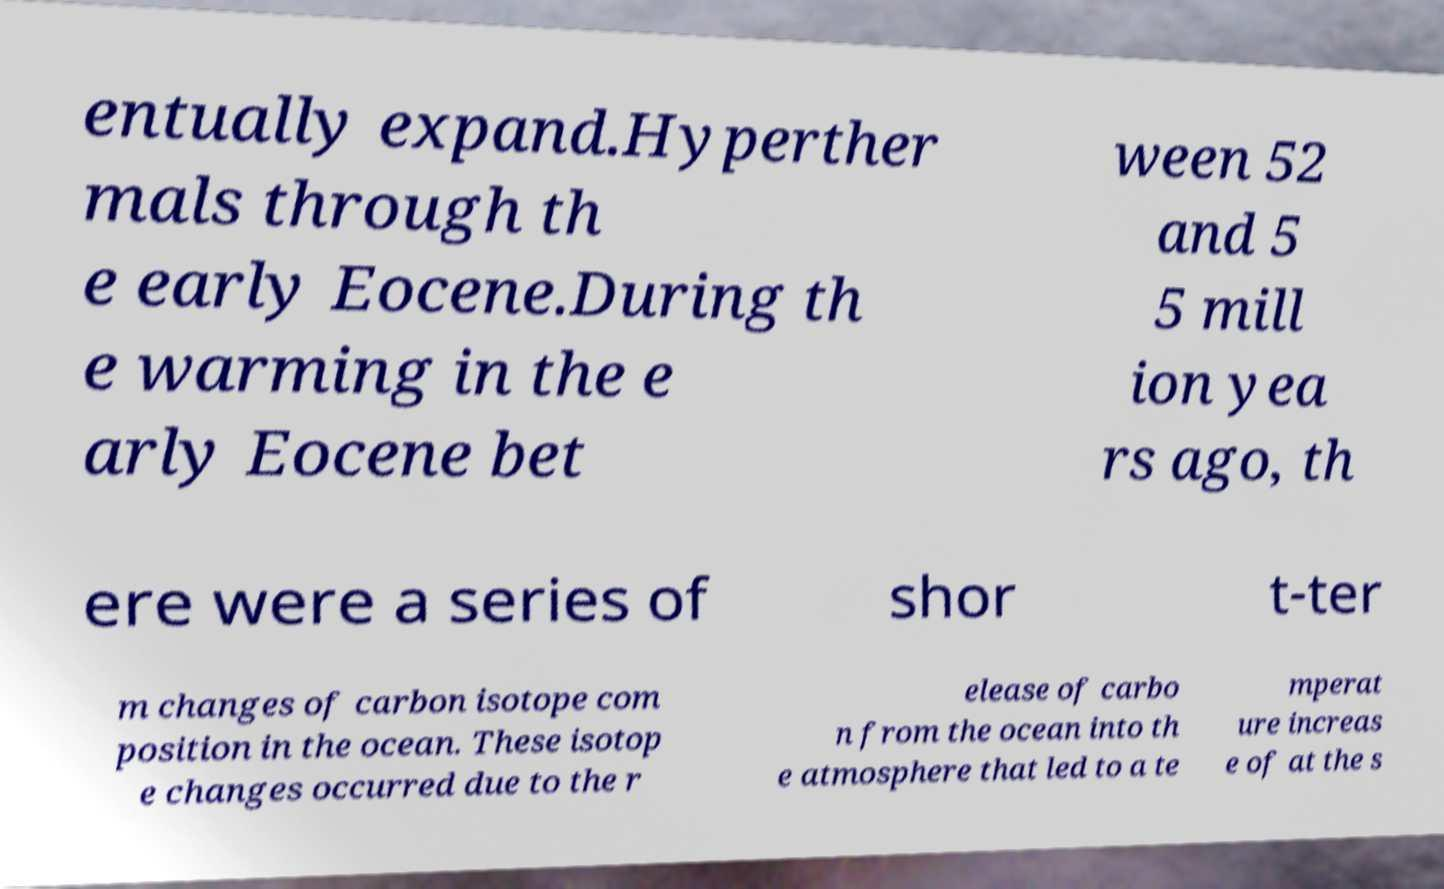There's text embedded in this image that I need extracted. Can you transcribe it verbatim? entually expand.Hyperther mals through th e early Eocene.During th e warming in the e arly Eocene bet ween 52 and 5 5 mill ion yea rs ago, th ere were a series of shor t-ter m changes of carbon isotope com position in the ocean. These isotop e changes occurred due to the r elease of carbo n from the ocean into th e atmosphere that led to a te mperat ure increas e of at the s 